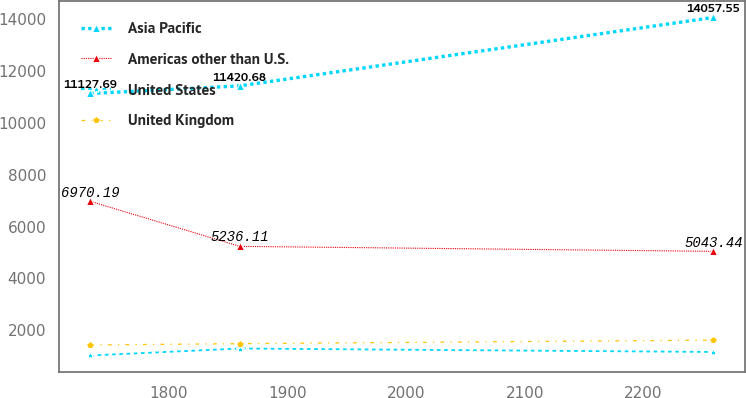Convert chart to OTSL. <chart><loc_0><loc_0><loc_500><loc_500><line_chart><ecel><fcel>Asia Pacific<fcel>Americas other than U.S.<fcel>United States<fcel>United Kingdom<nl><fcel>1733.99<fcel>11127.7<fcel>6970.19<fcel>1030.36<fcel>1436.06<nl><fcel>1859.68<fcel>11420.7<fcel>5236.11<fcel>1298.79<fcel>1486.21<nl><fcel>2258.96<fcel>14057.5<fcel>5043.44<fcel>1166.22<fcel>1621.89<nl></chart> 